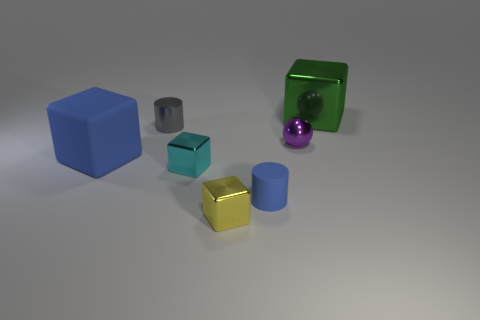Subtract all metallic cubes. How many cubes are left? 1 Subtract all blue cylinders. How many cylinders are left? 1 Subtract 1 gray cylinders. How many objects are left? 6 Subtract all cubes. How many objects are left? 3 Subtract all purple cubes. Subtract all blue cylinders. How many cubes are left? 4 Subtract all cyan cubes. How many blue spheres are left? 0 Subtract all tiny matte cylinders. Subtract all balls. How many objects are left? 5 Add 4 gray cylinders. How many gray cylinders are left? 5 Add 2 metallic blocks. How many metallic blocks exist? 5 Add 3 small cyan metal cubes. How many objects exist? 10 